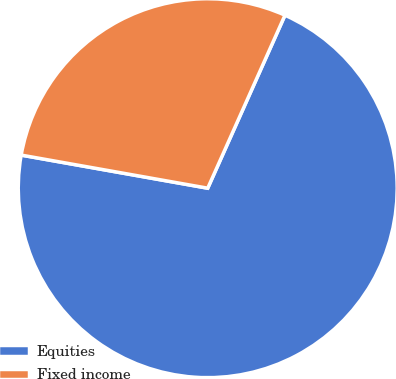Convert chart to OTSL. <chart><loc_0><loc_0><loc_500><loc_500><pie_chart><fcel>Equities<fcel>Fixed income<nl><fcel>71.11%<fcel>28.89%<nl></chart> 